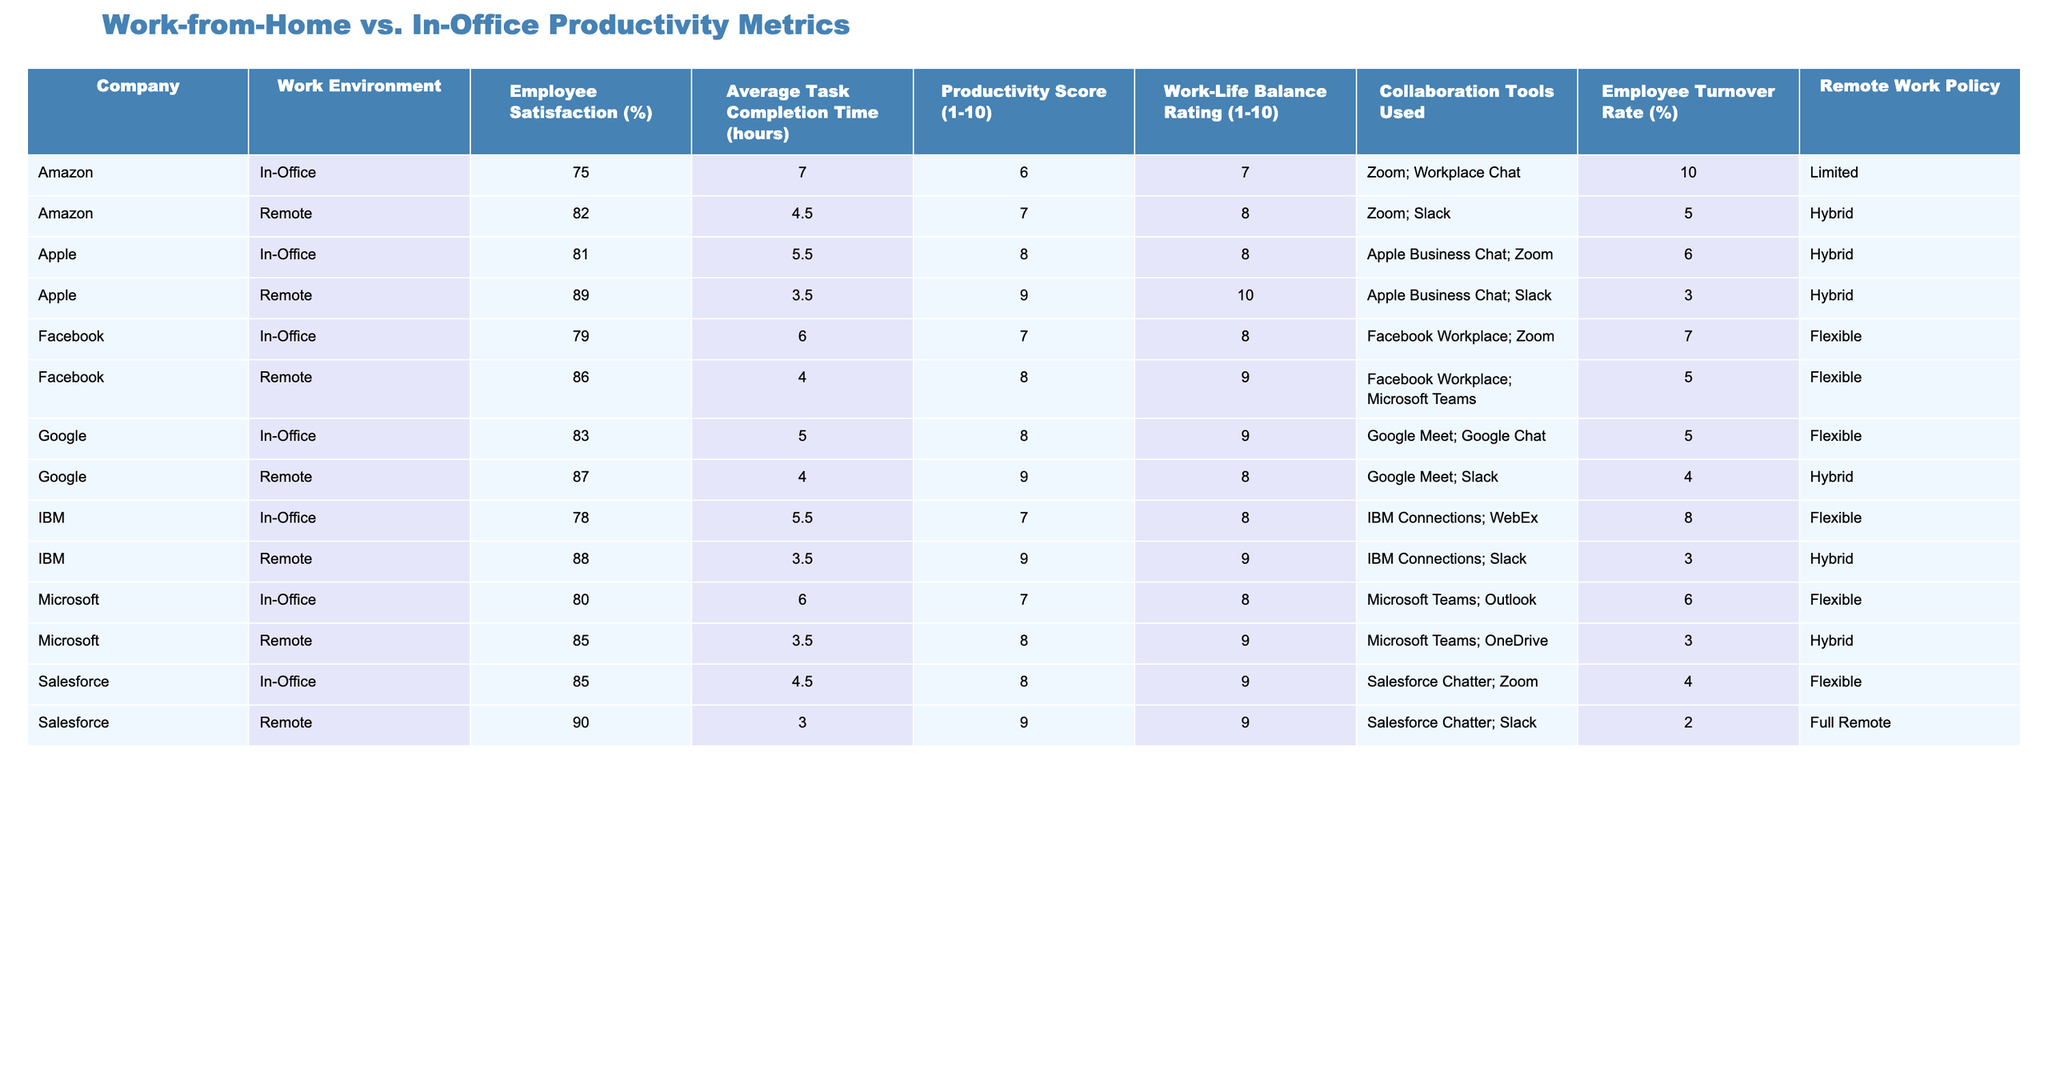What is the employee satisfaction percentage for Microsoft in a remote work environment? According to the table, Microsoft has an employee satisfaction percentage of 85% when employees work remotely.
Answer: 85% Which company has the highest productivity score in an in-office setting? Reviewing the table, Salesforce has the highest productivity score of 8 in an in-office environment.
Answer: Salesforce What is the average task completion time for employees working remotely across all companies? To find the average task completion time, we take the times for remote work (4, 3.5, 4.5, 3, 4, 3.5) and sum them up (4 + 3.5 + 4.5 + 3 + 4 + 3.5 = 22.5). There are 6 companies, so the average is 22.5/6 = 3.75 hours.
Answer: 3.75 hours Is the employee turnover rate for Apple lower in remote work compared to in-office work? Looking at the table, Apple's turnover rate in the remote environment is 3%, while it is 6% in the in-office setting. Therefore, it is lower.
Answer: Yes Which company shows the most significant difference in productivity scores between remote and in-office work? From the table, the difference in productivity scores is calculated as follows: Google (remote 9 - in-office 8 = 1), Microsoft (remote 8 - in-office 7 = 1), Amazon (remote 7 - in-office 6 = 1), IBM (remote 9 - in-office 7 = 2), Salesforce (remote 9 - in-office 8 = 1), Facebook (remote 8 - in-office 7 = 1), and Apple (remote 9 - in-office 8 = 1). The largest difference is with IBM, which has a productivity score difference of 2.
Answer: IBM Do all companies use collaboration tools in both remote and in-office environments? Upon inspection of the table, each company does employ collaboration tools for both work environments, so the answer is affirmative.
Answer: Yes What is the work-life balance rating for remote workers at Amazon? According to the data in the table, remote employees at Amazon have a work-life balance rating of 8.
Answer: 8 Which work environment has a lower average employee satisfaction across all companies? The employee satisfaction for in-office (average of 80.7) is derived from the values (83, 80, 75, 78, 85, 79, 81), totaling 566, divided by 7 gives about 80.7. The remote environment has an average of 84.7 (87, 85, 82, 88, 90, 86, 89) totaling 517 and divided by 7 gives about 84.7. Hence, in-office is lower.
Answer: In-Office What is the average productivity score for remote work settings across all companies? The productivity scores for remote work are (9, 8, 7, 9, 9, 8, 9). By summing these (9 + 8 + 7 + 9 + 9 + 8 + 9 = 61) and dividing by 7 gives an average score of approximately 8.71.
Answer: 8.71 